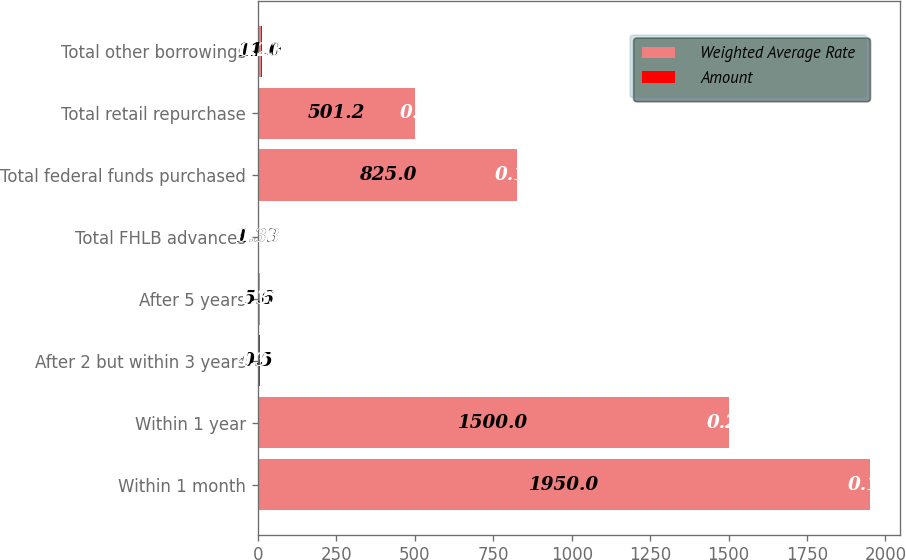Convert chart to OTSL. <chart><loc_0><loc_0><loc_500><loc_500><stacked_bar_chart><ecel><fcel>Within 1 month<fcel>Within 1 year<fcel>After 2 but within 3 years<fcel>After 5 years<fcel>Total FHLB advances<fcel>Total federal funds purchased<fcel>Total retail repurchase<fcel>Total other borrowings<nl><fcel>Weighted Average Rate<fcel>1950<fcel>1500<fcel>0.5<fcel>5.6<fcel>1.33<fcel>825<fcel>501.2<fcel>11<nl><fcel>Amount<fcel>0.19<fcel>0.21<fcel>4.37<fcel>1.33<fcel>0.38<fcel>0.16<fcel>0.2<fcel>0.23<nl></chart> 